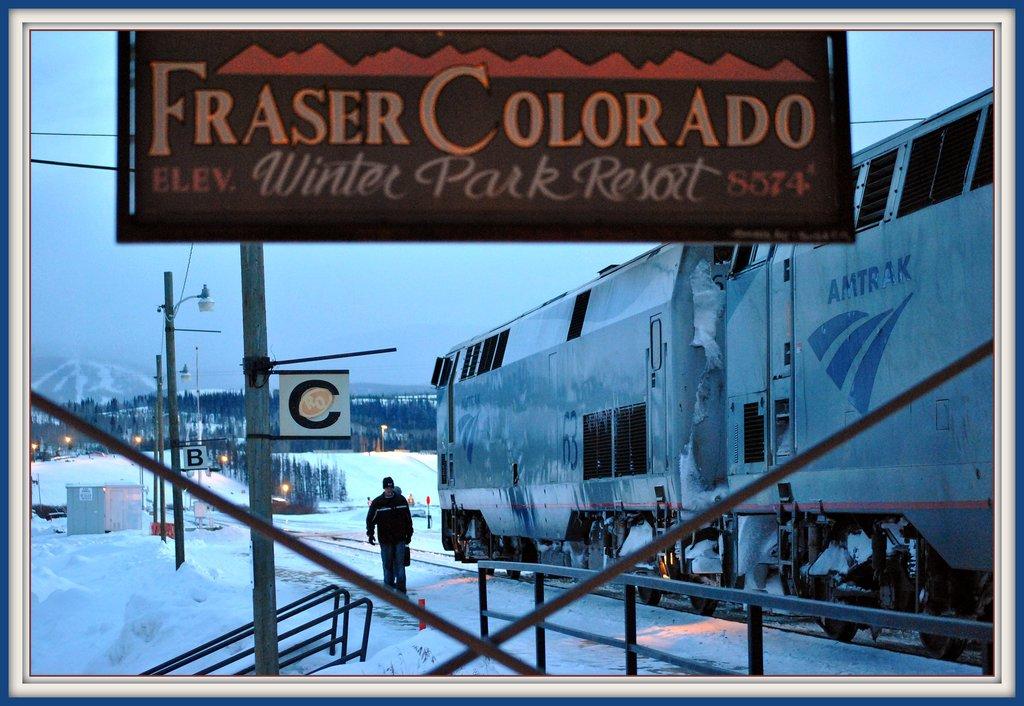Is this a winter park resort?
Provide a succinct answer. Yes. 